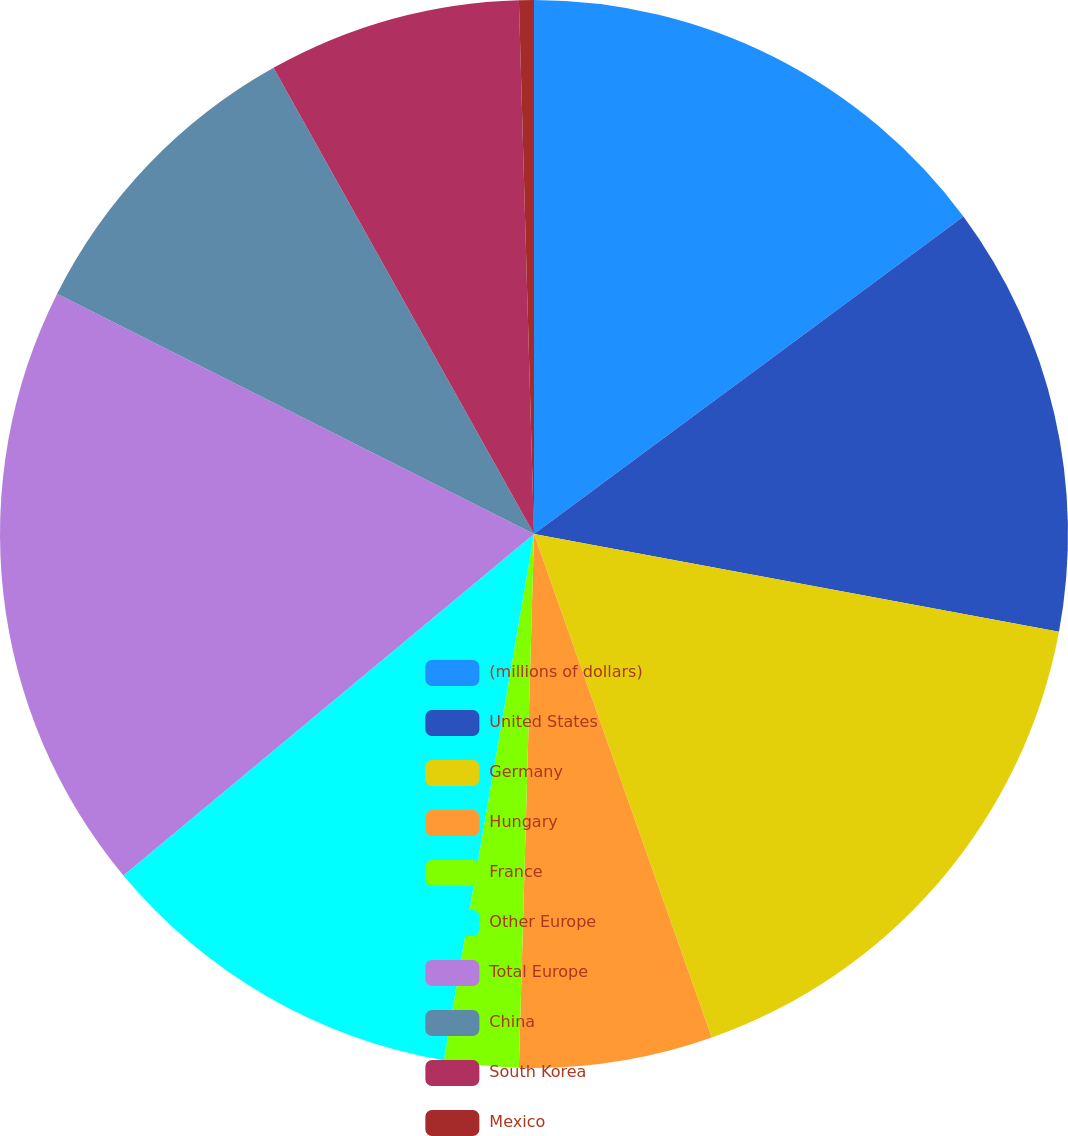<chart> <loc_0><loc_0><loc_500><loc_500><pie_chart><fcel>(millions of dollars)<fcel>United States<fcel>Germany<fcel>Hungary<fcel>France<fcel>Other Europe<fcel>Total Europe<fcel>China<fcel>South Korea<fcel>Mexico<nl><fcel>14.87%<fcel>13.06%<fcel>16.67%<fcel>5.85%<fcel>2.25%<fcel>11.26%<fcel>18.47%<fcel>9.46%<fcel>7.66%<fcel>0.45%<nl></chart> 